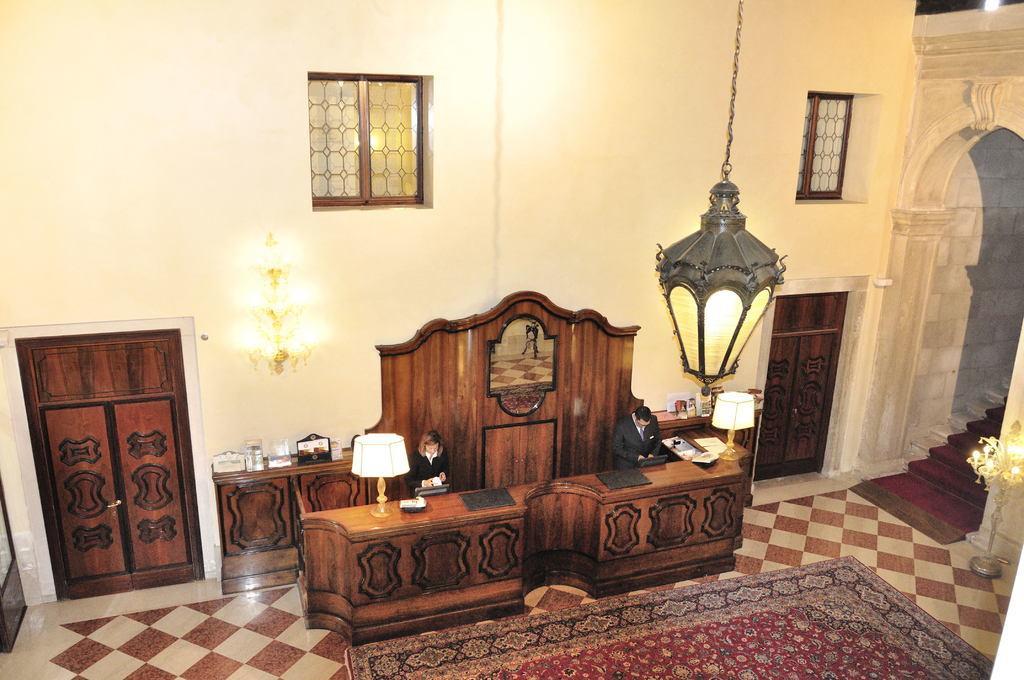Can you describe this image briefly? In this picture I can observe a reception desk. There are two lamps on either sides of the desk. There are two persons standing in front of the desk. On the right side there is a light hanged to the ceiling. I can observe doors on either sides of this picture. On the right side there are stairs. In the background there is a wall. 